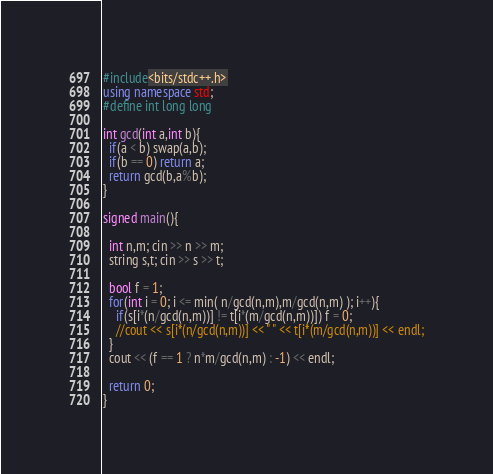Convert code to text. <code><loc_0><loc_0><loc_500><loc_500><_C++_>#include<bits/stdc++.h>
using namespace std;
#define int long long

int gcd(int a,int b){
  if(a < b) swap(a,b);
  if(b == 0) return a;
  return gcd(b,a%b);
}

signed main(){

  int n,m; cin >> n >> m;
  string s,t; cin >> s >> t;

  bool f = 1;
  for(int i = 0; i <= min( n/gcd(n,m),m/gcd(n,m) ); i++){
    if(s[i*(n/gcd(n,m))] != t[i*(m/gcd(n,m))]) f = 0;
    //cout << s[i*(n/gcd(n,m))] << " " << t[i*(m/gcd(n,m))] << endl;
  }
  cout << (f == 1 ? n*m/gcd(n,m) : -1) << endl;

  return 0;
}
</code> 